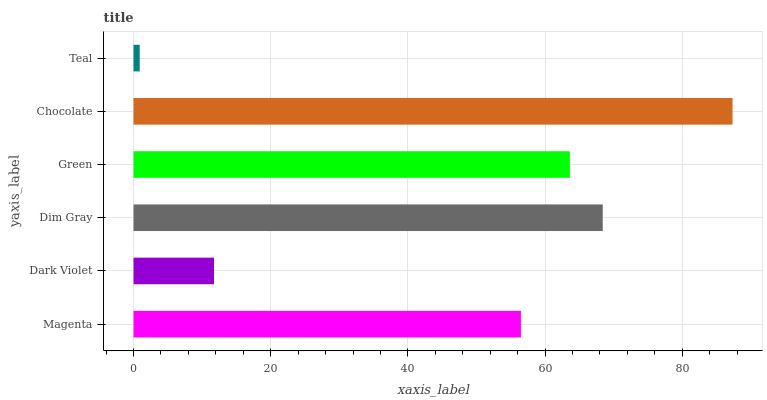Is Teal the minimum?
Answer yes or no. Yes. Is Chocolate the maximum?
Answer yes or no. Yes. Is Dark Violet the minimum?
Answer yes or no. No. Is Dark Violet the maximum?
Answer yes or no. No. Is Magenta greater than Dark Violet?
Answer yes or no. Yes. Is Dark Violet less than Magenta?
Answer yes or no. Yes. Is Dark Violet greater than Magenta?
Answer yes or no. No. Is Magenta less than Dark Violet?
Answer yes or no. No. Is Green the high median?
Answer yes or no. Yes. Is Magenta the low median?
Answer yes or no. Yes. Is Chocolate the high median?
Answer yes or no. No. Is Chocolate the low median?
Answer yes or no. No. 